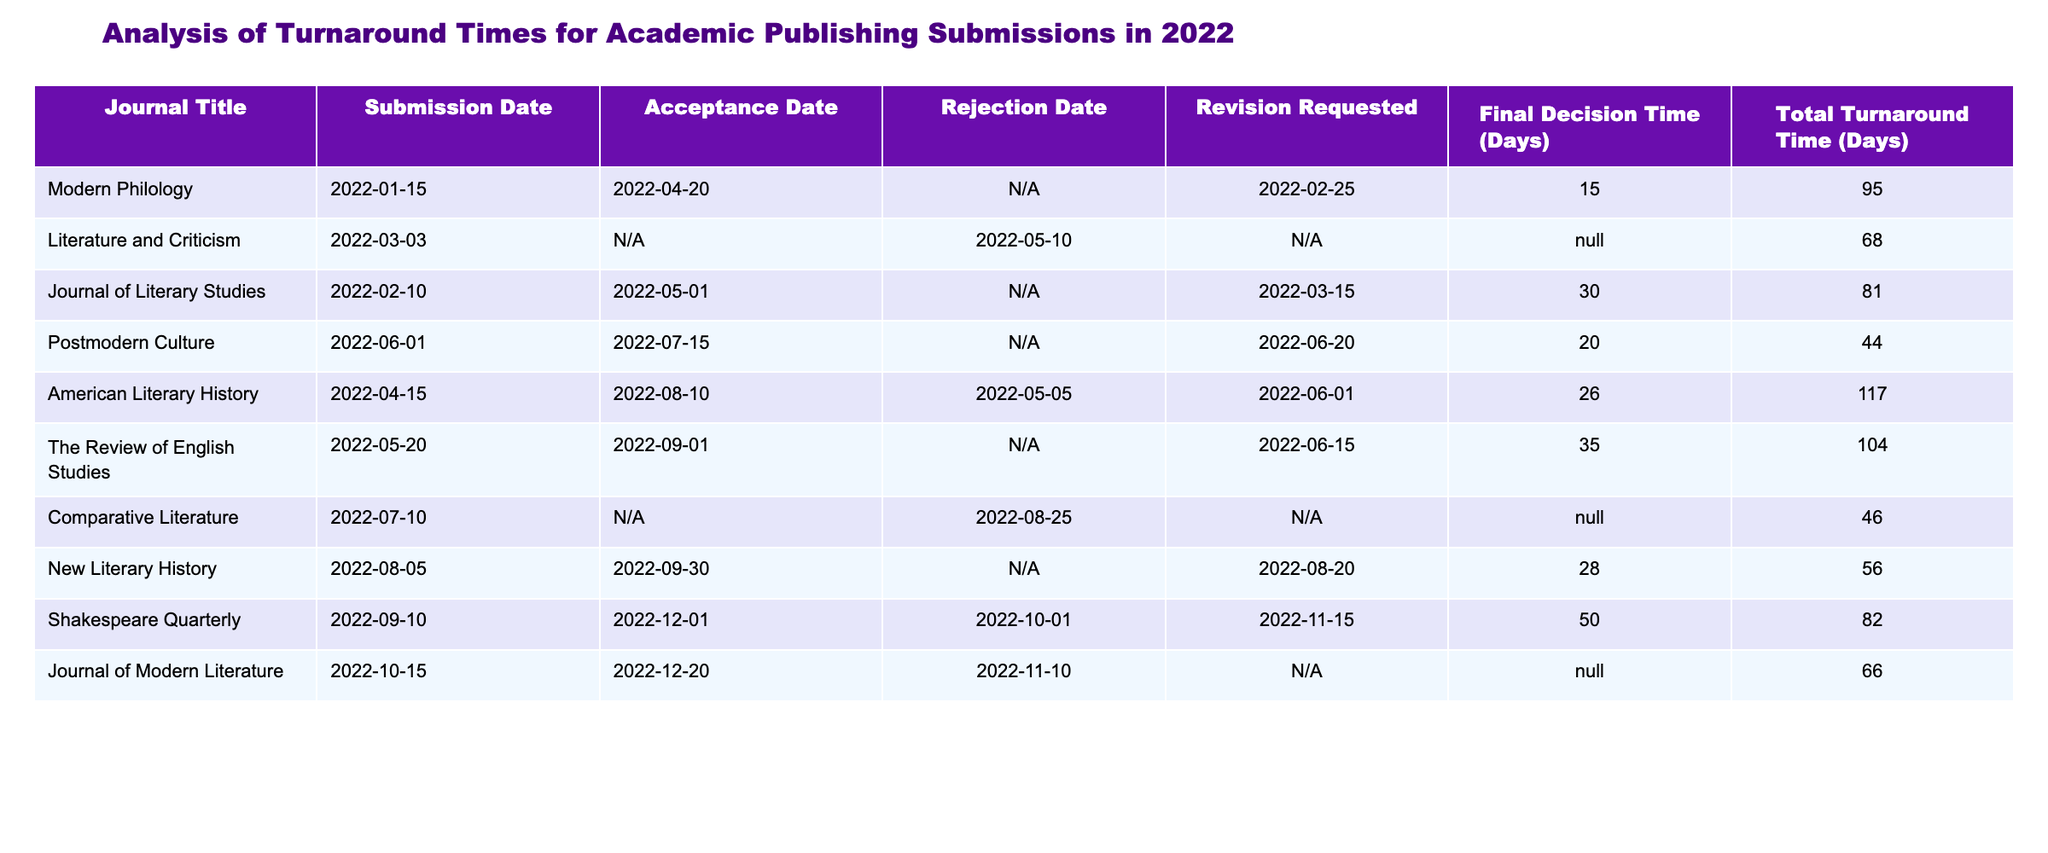What is the total turnaround time for the "Journal of Literary Studies"? In the table, I can locate the row for "Journal of Literary Studies." The column for Total Turnaround Time indicates the value next to it, which is 81 days.
Answer: 81 days Which journal had the longest final decision time? By examining the Final Decision Time (Days) column, I see that the highest value is 50 days for "Shakespeare Quarterly."
Answer: 50 days How many journals had a revision requested? By scanning through the Revision Requested column, I observe that "American Literary History," "Shakespeare Quarterly," and "Modern Philology" had revisions requested, totaling three journals.
Answer: 3 What is the average total turnaround time for all journals listed? To find the average, I total the values in the Total Turnaround Time column: 95 + 68 + 81 + 44 + 117 + 104 + 46 + 56 + 82 + 66 =  719. Then, I divide that by the number of journals, which is 10. The average is 719 / 10 = 71.9 days.
Answer: 71.9 days Was the acceptance date for "Comparative Literature" before July 1, 2022? Looking at the Acceptance Date column for "Comparative Literature," I see it is marked as "N/A." Therefore, there is no acceptance date recorded, so the statement is technically true because there is no acceptance before that date.
Answer: No 